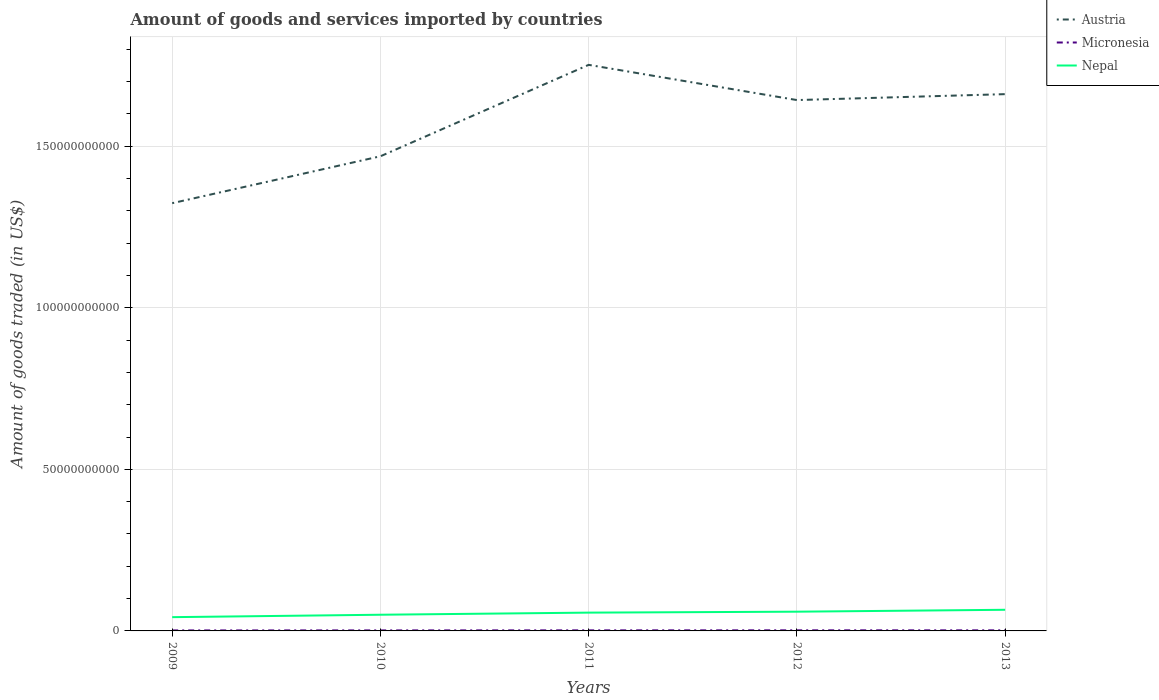How many different coloured lines are there?
Keep it short and to the point. 3. Does the line corresponding to Micronesia intersect with the line corresponding to Austria?
Your response must be concise. No. Across all years, what is the maximum total amount of goods and services imported in Austria?
Your answer should be very brief. 1.32e+11. In which year was the total amount of goods and services imported in Nepal maximum?
Provide a short and direct response. 2009. What is the total total amount of goods and services imported in Austria in the graph?
Ensure brevity in your answer.  -1.74e+1. What is the difference between the highest and the second highest total amount of goods and services imported in Austria?
Give a very brief answer. 4.28e+1. What is the difference between the highest and the lowest total amount of goods and services imported in Nepal?
Offer a very short reply. 3. How many years are there in the graph?
Ensure brevity in your answer.  5. What is the difference between two consecutive major ticks on the Y-axis?
Your answer should be compact. 5.00e+1. Does the graph contain any zero values?
Offer a very short reply. No. Does the graph contain grids?
Your answer should be compact. Yes. Where does the legend appear in the graph?
Your answer should be very brief. Top right. How many legend labels are there?
Ensure brevity in your answer.  3. How are the legend labels stacked?
Make the answer very short. Vertical. What is the title of the graph?
Provide a succinct answer. Amount of goods and services imported by countries. Does "Chad" appear as one of the legend labels in the graph?
Make the answer very short. No. What is the label or title of the Y-axis?
Provide a short and direct response. Amount of goods traded (in US$). What is the Amount of goods traded (in US$) in Austria in 2009?
Your response must be concise. 1.32e+11. What is the Amount of goods traded (in US$) in Micronesia in 2009?
Your answer should be compact. 1.53e+08. What is the Amount of goods traded (in US$) in Nepal in 2009?
Provide a short and direct response. 4.26e+09. What is the Amount of goods traded (in US$) in Austria in 2010?
Offer a terse response. 1.47e+11. What is the Amount of goods traded (in US$) of Micronesia in 2010?
Make the answer very short. 1.60e+08. What is the Amount of goods traded (in US$) in Nepal in 2010?
Provide a succinct answer. 5.01e+09. What is the Amount of goods traded (in US$) in Austria in 2011?
Offer a very short reply. 1.75e+11. What is the Amount of goods traded (in US$) of Micronesia in 2011?
Your answer should be compact. 1.74e+08. What is the Amount of goods traded (in US$) of Nepal in 2011?
Your response must be concise. 5.67e+09. What is the Amount of goods traded (in US$) in Austria in 2012?
Offer a terse response. 1.64e+11. What is the Amount of goods traded (in US$) in Micronesia in 2012?
Give a very brief answer. 1.83e+08. What is the Amount of goods traded (in US$) in Nepal in 2012?
Provide a succinct answer. 5.95e+09. What is the Amount of goods traded (in US$) in Austria in 2013?
Offer a terse response. 1.66e+11. What is the Amount of goods traded (in US$) of Micronesia in 2013?
Your answer should be very brief. 1.79e+08. What is the Amount of goods traded (in US$) of Nepal in 2013?
Make the answer very short. 6.54e+09. Across all years, what is the maximum Amount of goods traded (in US$) in Austria?
Offer a terse response. 1.75e+11. Across all years, what is the maximum Amount of goods traded (in US$) of Micronesia?
Offer a very short reply. 1.83e+08. Across all years, what is the maximum Amount of goods traded (in US$) of Nepal?
Provide a succinct answer. 6.54e+09. Across all years, what is the minimum Amount of goods traded (in US$) of Austria?
Your response must be concise. 1.32e+11. Across all years, what is the minimum Amount of goods traded (in US$) of Micronesia?
Provide a short and direct response. 1.53e+08. Across all years, what is the minimum Amount of goods traded (in US$) in Nepal?
Give a very brief answer. 4.26e+09. What is the total Amount of goods traded (in US$) in Austria in the graph?
Make the answer very short. 7.85e+11. What is the total Amount of goods traded (in US$) in Micronesia in the graph?
Make the answer very short. 8.50e+08. What is the total Amount of goods traded (in US$) of Nepal in the graph?
Your response must be concise. 2.74e+1. What is the difference between the Amount of goods traded (in US$) of Austria in 2009 and that in 2010?
Make the answer very short. -1.45e+1. What is the difference between the Amount of goods traded (in US$) of Micronesia in 2009 and that in 2010?
Provide a short and direct response. -6.59e+06. What is the difference between the Amount of goods traded (in US$) of Nepal in 2009 and that in 2010?
Ensure brevity in your answer.  -7.50e+08. What is the difference between the Amount of goods traded (in US$) of Austria in 2009 and that in 2011?
Your response must be concise. -4.28e+1. What is the difference between the Amount of goods traded (in US$) in Micronesia in 2009 and that in 2011?
Provide a succinct answer. -2.10e+07. What is the difference between the Amount of goods traded (in US$) in Nepal in 2009 and that in 2011?
Your response must be concise. -1.41e+09. What is the difference between the Amount of goods traded (in US$) in Austria in 2009 and that in 2012?
Your answer should be very brief. -3.19e+1. What is the difference between the Amount of goods traded (in US$) of Micronesia in 2009 and that in 2012?
Your answer should be compact. -2.98e+07. What is the difference between the Amount of goods traded (in US$) of Nepal in 2009 and that in 2012?
Ensure brevity in your answer.  -1.69e+09. What is the difference between the Amount of goods traded (in US$) in Austria in 2009 and that in 2013?
Give a very brief answer. -3.37e+1. What is the difference between the Amount of goods traded (in US$) in Micronesia in 2009 and that in 2013?
Offer a terse response. -2.55e+07. What is the difference between the Amount of goods traded (in US$) of Nepal in 2009 and that in 2013?
Provide a succinct answer. -2.28e+09. What is the difference between the Amount of goods traded (in US$) of Austria in 2010 and that in 2011?
Offer a terse response. -2.83e+1. What is the difference between the Amount of goods traded (in US$) in Micronesia in 2010 and that in 2011?
Provide a succinct answer. -1.44e+07. What is the difference between the Amount of goods traded (in US$) in Nepal in 2010 and that in 2011?
Keep it short and to the point. -6.56e+08. What is the difference between the Amount of goods traded (in US$) of Austria in 2010 and that in 2012?
Ensure brevity in your answer.  -1.74e+1. What is the difference between the Amount of goods traded (in US$) in Micronesia in 2010 and that in 2012?
Provide a succinct answer. -2.32e+07. What is the difference between the Amount of goods traded (in US$) in Nepal in 2010 and that in 2012?
Your response must be concise. -9.42e+08. What is the difference between the Amount of goods traded (in US$) in Austria in 2010 and that in 2013?
Your answer should be very brief. -1.92e+1. What is the difference between the Amount of goods traded (in US$) of Micronesia in 2010 and that in 2013?
Give a very brief answer. -1.89e+07. What is the difference between the Amount of goods traded (in US$) of Nepal in 2010 and that in 2013?
Ensure brevity in your answer.  -1.53e+09. What is the difference between the Amount of goods traded (in US$) of Austria in 2011 and that in 2012?
Your response must be concise. 1.09e+1. What is the difference between the Amount of goods traded (in US$) of Micronesia in 2011 and that in 2012?
Provide a succinct answer. -8.79e+06. What is the difference between the Amount of goods traded (in US$) of Nepal in 2011 and that in 2012?
Offer a very short reply. -2.86e+08. What is the difference between the Amount of goods traded (in US$) in Austria in 2011 and that in 2013?
Your answer should be very brief. 9.06e+09. What is the difference between the Amount of goods traded (in US$) of Micronesia in 2011 and that in 2013?
Make the answer very short. -4.51e+06. What is the difference between the Amount of goods traded (in US$) of Nepal in 2011 and that in 2013?
Your answer should be compact. -8.78e+08. What is the difference between the Amount of goods traded (in US$) in Austria in 2012 and that in 2013?
Offer a very short reply. -1.83e+09. What is the difference between the Amount of goods traded (in US$) of Micronesia in 2012 and that in 2013?
Offer a terse response. 4.27e+06. What is the difference between the Amount of goods traded (in US$) of Nepal in 2012 and that in 2013?
Provide a succinct answer. -5.92e+08. What is the difference between the Amount of goods traded (in US$) in Austria in 2009 and the Amount of goods traded (in US$) in Micronesia in 2010?
Your response must be concise. 1.32e+11. What is the difference between the Amount of goods traded (in US$) in Austria in 2009 and the Amount of goods traded (in US$) in Nepal in 2010?
Your answer should be very brief. 1.27e+11. What is the difference between the Amount of goods traded (in US$) of Micronesia in 2009 and the Amount of goods traded (in US$) of Nepal in 2010?
Your answer should be very brief. -4.86e+09. What is the difference between the Amount of goods traded (in US$) in Austria in 2009 and the Amount of goods traded (in US$) in Micronesia in 2011?
Offer a terse response. 1.32e+11. What is the difference between the Amount of goods traded (in US$) of Austria in 2009 and the Amount of goods traded (in US$) of Nepal in 2011?
Give a very brief answer. 1.27e+11. What is the difference between the Amount of goods traded (in US$) of Micronesia in 2009 and the Amount of goods traded (in US$) of Nepal in 2011?
Make the answer very short. -5.51e+09. What is the difference between the Amount of goods traded (in US$) of Austria in 2009 and the Amount of goods traded (in US$) of Micronesia in 2012?
Give a very brief answer. 1.32e+11. What is the difference between the Amount of goods traded (in US$) in Austria in 2009 and the Amount of goods traded (in US$) in Nepal in 2012?
Ensure brevity in your answer.  1.26e+11. What is the difference between the Amount of goods traded (in US$) of Micronesia in 2009 and the Amount of goods traded (in US$) of Nepal in 2012?
Ensure brevity in your answer.  -5.80e+09. What is the difference between the Amount of goods traded (in US$) in Austria in 2009 and the Amount of goods traded (in US$) in Micronesia in 2013?
Ensure brevity in your answer.  1.32e+11. What is the difference between the Amount of goods traded (in US$) in Austria in 2009 and the Amount of goods traded (in US$) in Nepal in 2013?
Your response must be concise. 1.26e+11. What is the difference between the Amount of goods traded (in US$) in Micronesia in 2009 and the Amount of goods traded (in US$) in Nepal in 2013?
Keep it short and to the point. -6.39e+09. What is the difference between the Amount of goods traded (in US$) of Austria in 2010 and the Amount of goods traded (in US$) of Micronesia in 2011?
Provide a short and direct response. 1.47e+11. What is the difference between the Amount of goods traded (in US$) in Austria in 2010 and the Amount of goods traded (in US$) in Nepal in 2011?
Your response must be concise. 1.41e+11. What is the difference between the Amount of goods traded (in US$) of Micronesia in 2010 and the Amount of goods traded (in US$) of Nepal in 2011?
Provide a short and direct response. -5.51e+09. What is the difference between the Amount of goods traded (in US$) of Austria in 2010 and the Amount of goods traded (in US$) of Micronesia in 2012?
Offer a very short reply. 1.47e+11. What is the difference between the Amount of goods traded (in US$) of Austria in 2010 and the Amount of goods traded (in US$) of Nepal in 2012?
Provide a succinct answer. 1.41e+11. What is the difference between the Amount of goods traded (in US$) in Micronesia in 2010 and the Amount of goods traded (in US$) in Nepal in 2012?
Provide a short and direct response. -5.79e+09. What is the difference between the Amount of goods traded (in US$) in Austria in 2010 and the Amount of goods traded (in US$) in Micronesia in 2013?
Offer a terse response. 1.47e+11. What is the difference between the Amount of goods traded (in US$) of Austria in 2010 and the Amount of goods traded (in US$) of Nepal in 2013?
Ensure brevity in your answer.  1.40e+11. What is the difference between the Amount of goods traded (in US$) of Micronesia in 2010 and the Amount of goods traded (in US$) of Nepal in 2013?
Provide a succinct answer. -6.38e+09. What is the difference between the Amount of goods traded (in US$) of Austria in 2011 and the Amount of goods traded (in US$) of Micronesia in 2012?
Offer a terse response. 1.75e+11. What is the difference between the Amount of goods traded (in US$) of Austria in 2011 and the Amount of goods traded (in US$) of Nepal in 2012?
Your response must be concise. 1.69e+11. What is the difference between the Amount of goods traded (in US$) in Micronesia in 2011 and the Amount of goods traded (in US$) in Nepal in 2012?
Your answer should be compact. -5.78e+09. What is the difference between the Amount of goods traded (in US$) of Austria in 2011 and the Amount of goods traded (in US$) of Micronesia in 2013?
Your response must be concise. 1.75e+11. What is the difference between the Amount of goods traded (in US$) in Austria in 2011 and the Amount of goods traded (in US$) in Nepal in 2013?
Make the answer very short. 1.69e+11. What is the difference between the Amount of goods traded (in US$) in Micronesia in 2011 and the Amount of goods traded (in US$) in Nepal in 2013?
Your answer should be compact. -6.37e+09. What is the difference between the Amount of goods traded (in US$) in Austria in 2012 and the Amount of goods traded (in US$) in Micronesia in 2013?
Provide a succinct answer. 1.64e+11. What is the difference between the Amount of goods traded (in US$) of Austria in 2012 and the Amount of goods traded (in US$) of Nepal in 2013?
Your answer should be compact. 1.58e+11. What is the difference between the Amount of goods traded (in US$) of Micronesia in 2012 and the Amount of goods traded (in US$) of Nepal in 2013?
Provide a succinct answer. -6.36e+09. What is the average Amount of goods traded (in US$) in Austria per year?
Offer a very short reply. 1.57e+11. What is the average Amount of goods traded (in US$) of Micronesia per year?
Your answer should be compact. 1.70e+08. What is the average Amount of goods traded (in US$) in Nepal per year?
Your response must be concise. 5.49e+09. In the year 2009, what is the difference between the Amount of goods traded (in US$) in Austria and Amount of goods traded (in US$) in Micronesia?
Offer a terse response. 1.32e+11. In the year 2009, what is the difference between the Amount of goods traded (in US$) in Austria and Amount of goods traded (in US$) in Nepal?
Your answer should be compact. 1.28e+11. In the year 2009, what is the difference between the Amount of goods traded (in US$) of Micronesia and Amount of goods traded (in US$) of Nepal?
Provide a short and direct response. -4.11e+09. In the year 2010, what is the difference between the Amount of goods traded (in US$) in Austria and Amount of goods traded (in US$) in Micronesia?
Your response must be concise. 1.47e+11. In the year 2010, what is the difference between the Amount of goods traded (in US$) of Austria and Amount of goods traded (in US$) of Nepal?
Your response must be concise. 1.42e+11. In the year 2010, what is the difference between the Amount of goods traded (in US$) of Micronesia and Amount of goods traded (in US$) of Nepal?
Offer a terse response. -4.85e+09. In the year 2011, what is the difference between the Amount of goods traded (in US$) in Austria and Amount of goods traded (in US$) in Micronesia?
Make the answer very short. 1.75e+11. In the year 2011, what is the difference between the Amount of goods traded (in US$) of Austria and Amount of goods traded (in US$) of Nepal?
Your response must be concise. 1.70e+11. In the year 2011, what is the difference between the Amount of goods traded (in US$) in Micronesia and Amount of goods traded (in US$) in Nepal?
Provide a succinct answer. -5.49e+09. In the year 2012, what is the difference between the Amount of goods traded (in US$) of Austria and Amount of goods traded (in US$) of Micronesia?
Your answer should be compact. 1.64e+11. In the year 2012, what is the difference between the Amount of goods traded (in US$) of Austria and Amount of goods traded (in US$) of Nepal?
Provide a short and direct response. 1.58e+11. In the year 2012, what is the difference between the Amount of goods traded (in US$) of Micronesia and Amount of goods traded (in US$) of Nepal?
Make the answer very short. -5.77e+09. In the year 2013, what is the difference between the Amount of goods traded (in US$) of Austria and Amount of goods traded (in US$) of Micronesia?
Your answer should be compact. 1.66e+11. In the year 2013, what is the difference between the Amount of goods traded (in US$) of Austria and Amount of goods traded (in US$) of Nepal?
Make the answer very short. 1.60e+11. In the year 2013, what is the difference between the Amount of goods traded (in US$) of Micronesia and Amount of goods traded (in US$) of Nepal?
Offer a very short reply. -6.36e+09. What is the ratio of the Amount of goods traded (in US$) in Austria in 2009 to that in 2010?
Your answer should be compact. 0.9. What is the ratio of the Amount of goods traded (in US$) in Micronesia in 2009 to that in 2010?
Provide a short and direct response. 0.96. What is the ratio of the Amount of goods traded (in US$) of Nepal in 2009 to that in 2010?
Your answer should be compact. 0.85. What is the ratio of the Amount of goods traded (in US$) in Austria in 2009 to that in 2011?
Your answer should be very brief. 0.76. What is the ratio of the Amount of goods traded (in US$) of Micronesia in 2009 to that in 2011?
Give a very brief answer. 0.88. What is the ratio of the Amount of goods traded (in US$) in Nepal in 2009 to that in 2011?
Give a very brief answer. 0.75. What is the ratio of the Amount of goods traded (in US$) of Austria in 2009 to that in 2012?
Your answer should be compact. 0.81. What is the ratio of the Amount of goods traded (in US$) in Micronesia in 2009 to that in 2012?
Provide a short and direct response. 0.84. What is the ratio of the Amount of goods traded (in US$) in Nepal in 2009 to that in 2012?
Provide a succinct answer. 0.72. What is the ratio of the Amount of goods traded (in US$) in Austria in 2009 to that in 2013?
Ensure brevity in your answer.  0.8. What is the ratio of the Amount of goods traded (in US$) of Micronesia in 2009 to that in 2013?
Your response must be concise. 0.86. What is the ratio of the Amount of goods traded (in US$) in Nepal in 2009 to that in 2013?
Offer a terse response. 0.65. What is the ratio of the Amount of goods traded (in US$) of Austria in 2010 to that in 2011?
Ensure brevity in your answer.  0.84. What is the ratio of the Amount of goods traded (in US$) of Micronesia in 2010 to that in 2011?
Keep it short and to the point. 0.92. What is the ratio of the Amount of goods traded (in US$) of Nepal in 2010 to that in 2011?
Your response must be concise. 0.88. What is the ratio of the Amount of goods traded (in US$) in Austria in 2010 to that in 2012?
Make the answer very short. 0.89. What is the ratio of the Amount of goods traded (in US$) of Micronesia in 2010 to that in 2012?
Provide a short and direct response. 0.87. What is the ratio of the Amount of goods traded (in US$) in Nepal in 2010 to that in 2012?
Ensure brevity in your answer.  0.84. What is the ratio of the Amount of goods traded (in US$) of Austria in 2010 to that in 2013?
Provide a short and direct response. 0.88. What is the ratio of the Amount of goods traded (in US$) in Micronesia in 2010 to that in 2013?
Ensure brevity in your answer.  0.89. What is the ratio of the Amount of goods traded (in US$) of Nepal in 2010 to that in 2013?
Offer a terse response. 0.77. What is the ratio of the Amount of goods traded (in US$) of Austria in 2011 to that in 2012?
Offer a very short reply. 1.07. What is the ratio of the Amount of goods traded (in US$) of Micronesia in 2011 to that in 2012?
Keep it short and to the point. 0.95. What is the ratio of the Amount of goods traded (in US$) of Nepal in 2011 to that in 2012?
Provide a short and direct response. 0.95. What is the ratio of the Amount of goods traded (in US$) of Austria in 2011 to that in 2013?
Your answer should be very brief. 1.05. What is the ratio of the Amount of goods traded (in US$) in Micronesia in 2011 to that in 2013?
Keep it short and to the point. 0.97. What is the ratio of the Amount of goods traded (in US$) in Nepal in 2011 to that in 2013?
Give a very brief answer. 0.87. What is the ratio of the Amount of goods traded (in US$) of Austria in 2012 to that in 2013?
Offer a very short reply. 0.99. What is the ratio of the Amount of goods traded (in US$) in Micronesia in 2012 to that in 2013?
Provide a short and direct response. 1.02. What is the ratio of the Amount of goods traded (in US$) of Nepal in 2012 to that in 2013?
Offer a terse response. 0.91. What is the difference between the highest and the second highest Amount of goods traded (in US$) of Austria?
Offer a terse response. 9.06e+09. What is the difference between the highest and the second highest Amount of goods traded (in US$) in Micronesia?
Ensure brevity in your answer.  4.27e+06. What is the difference between the highest and the second highest Amount of goods traded (in US$) of Nepal?
Your answer should be compact. 5.92e+08. What is the difference between the highest and the lowest Amount of goods traded (in US$) in Austria?
Keep it short and to the point. 4.28e+1. What is the difference between the highest and the lowest Amount of goods traded (in US$) in Micronesia?
Your answer should be very brief. 2.98e+07. What is the difference between the highest and the lowest Amount of goods traded (in US$) of Nepal?
Your answer should be compact. 2.28e+09. 